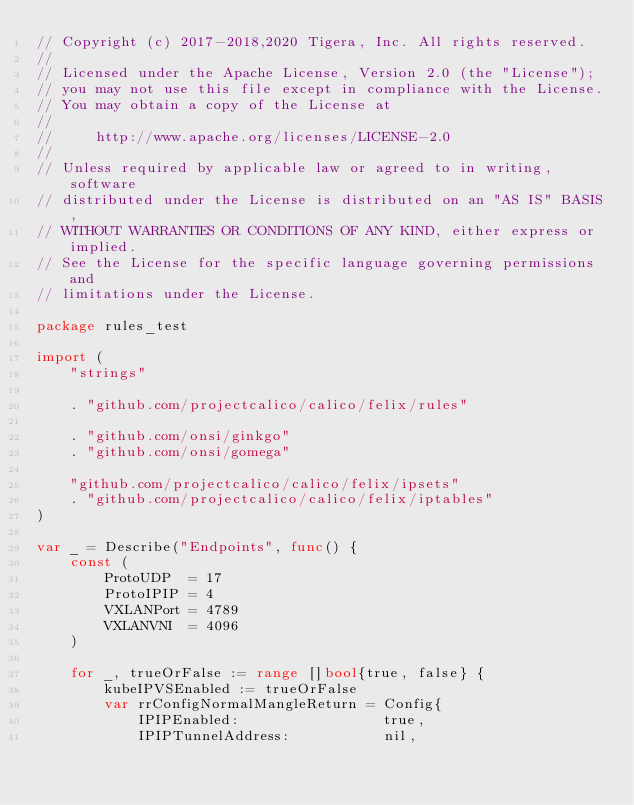<code> <loc_0><loc_0><loc_500><loc_500><_Go_>// Copyright (c) 2017-2018,2020 Tigera, Inc. All rights reserved.
//
// Licensed under the Apache License, Version 2.0 (the "License");
// you may not use this file except in compliance with the License.
// You may obtain a copy of the License at
//
//     http://www.apache.org/licenses/LICENSE-2.0
//
// Unless required by applicable law or agreed to in writing, software
// distributed under the License is distributed on an "AS IS" BASIS,
// WITHOUT WARRANTIES OR CONDITIONS OF ANY KIND, either express or implied.
// See the License for the specific language governing permissions and
// limitations under the License.

package rules_test

import (
	"strings"

	. "github.com/projectcalico/calico/felix/rules"

	. "github.com/onsi/ginkgo"
	. "github.com/onsi/gomega"

	"github.com/projectcalico/calico/felix/ipsets"
	. "github.com/projectcalico/calico/felix/iptables"
)

var _ = Describe("Endpoints", func() {
	const (
		ProtoUDP  = 17
		ProtoIPIP = 4
		VXLANPort = 4789
		VXLANVNI  = 4096
	)

	for _, trueOrFalse := range []bool{true, false} {
		kubeIPVSEnabled := trueOrFalse
		var rrConfigNormalMangleReturn = Config{
			IPIPEnabled:                 true,
			IPIPTunnelAddress:           nil,</code> 